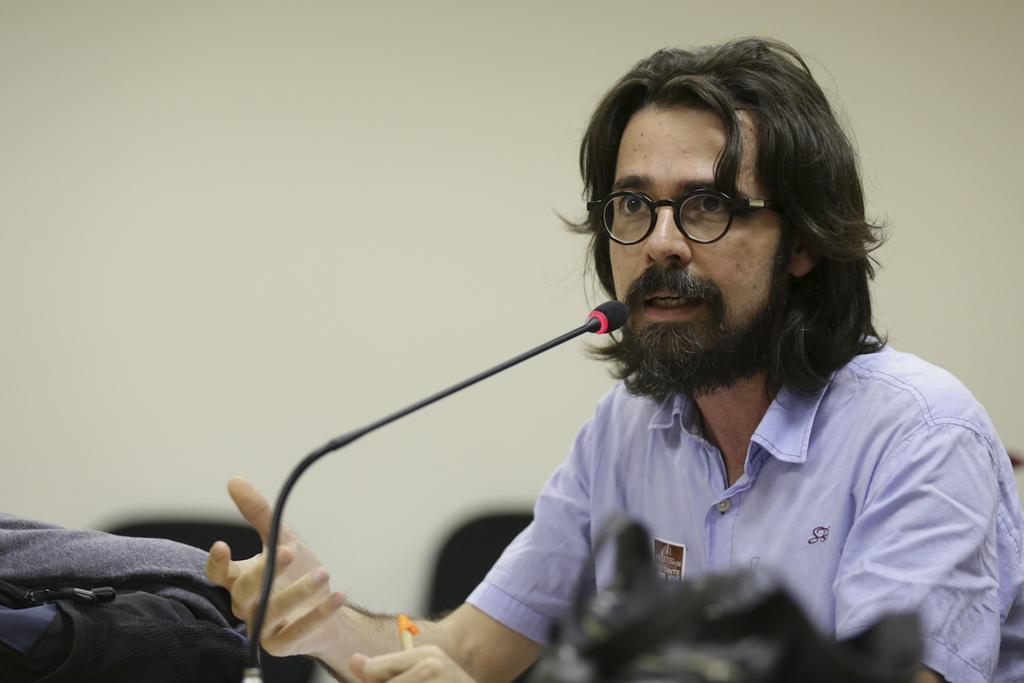Could you give a brief overview of what you see in this image? Here in this picture we can see a person speaking in the microphone, which is present in front of him on a table and beside him we can see a bag present and we can see spectacles on him. 